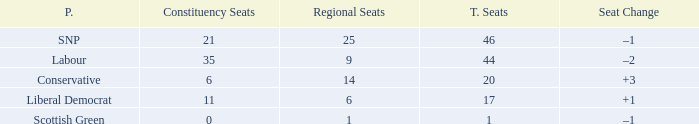How many regional seats were there with the SNP party and where the number of total seats was bigger than 46? 0.0. 